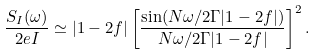Convert formula to latex. <formula><loc_0><loc_0><loc_500><loc_500>\frac { S _ { I } ( \omega ) } { 2 e I } \simeq | 1 - 2 f | \left [ \frac { \sin ( N \omega / 2 \Gamma | 1 - 2 f | ) } { N \omega / 2 \Gamma | 1 - 2 f | } \right ] ^ { 2 } .</formula> 